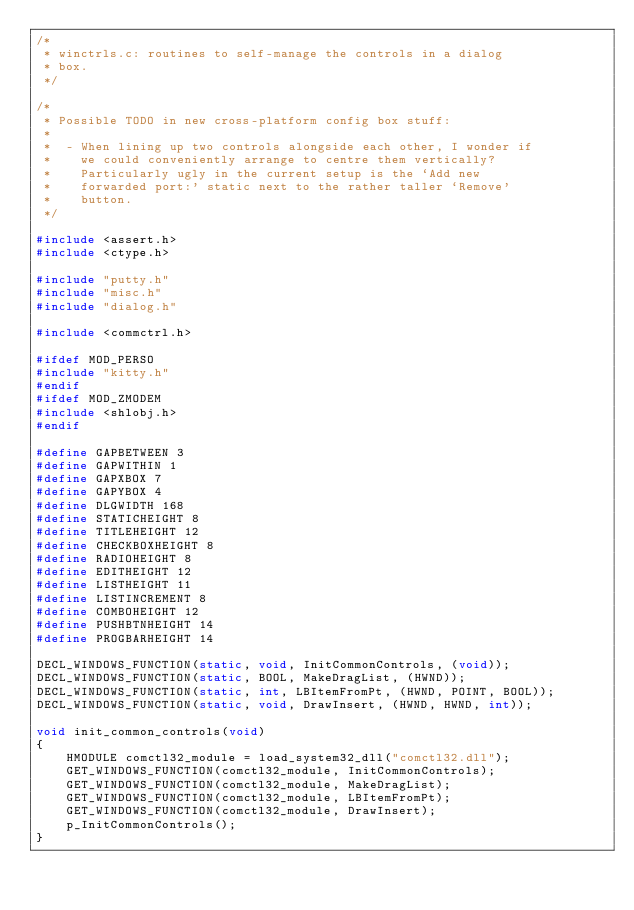<code> <loc_0><loc_0><loc_500><loc_500><_C_>/*
 * winctrls.c: routines to self-manage the controls in a dialog
 * box.
 */

/*
 * Possible TODO in new cross-platform config box stuff:
 *
 *  - When lining up two controls alongside each other, I wonder if
 *    we could conveniently arrange to centre them vertically?
 *    Particularly ugly in the current setup is the `Add new
 *    forwarded port:' static next to the rather taller `Remove'
 *    button.
 */

#include <assert.h>
#include <ctype.h>

#include "putty.h"
#include "misc.h"
#include "dialog.h"

#include <commctrl.h>

#ifdef MOD_PERSO
#include "kitty.h"
#endif
#ifdef MOD_ZMODEM
#include <shlobj.h>
#endif

#define GAPBETWEEN 3
#define GAPWITHIN 1
#define GAPXBOX 7
#define GAPYBOX 4
#define DLGWIDTH 168
#define STATICHEIGHT 8
#define TITLEHEIGHT 12
#define CHECKBOXHEIGHT 8
#define RADIOHEIGHT 8
#define EDITHEIGHT 12
#define LISTHEIGHT 11
#define LISTINCREMENT 8
#define COMBOHEIGHT 12
#define PUSHBTNHEIGHT 14
#define PROGBARHEIGHT 14

DECL_WINDOWS_FUNCTION(static, void, InitCommonControls, (void));
DECL_WINDOWS_FUNCTION(static, BOOL, MakeDragList, (HWND));
DECL_WINDOWS_FUNCTION(static, int, LBItemFromPt, (HWND, POINT, BOOL));
DECL_WINDOWS_FUNCTION(static, void, DrawInsert, (HWND, HWND, int));

void init_common_controls(void)
{
    HMODULE comctl32_module = load_system32_dll("comctl32.dll");
    GET_WINDOWS_FUNCTION(comctl32_module, InitCommonControls);
    GET_WINDOWS_FUNCTION(comctl32_module, MakeDragList);
    GET_WINDOWS_FUNCTION(comctl32_module, LBItemFromPt);
    GET_WINDOWS_FUNCTION(comctl32_module, DrawInsert);
    p_InitCommonControls();
}
</code> 